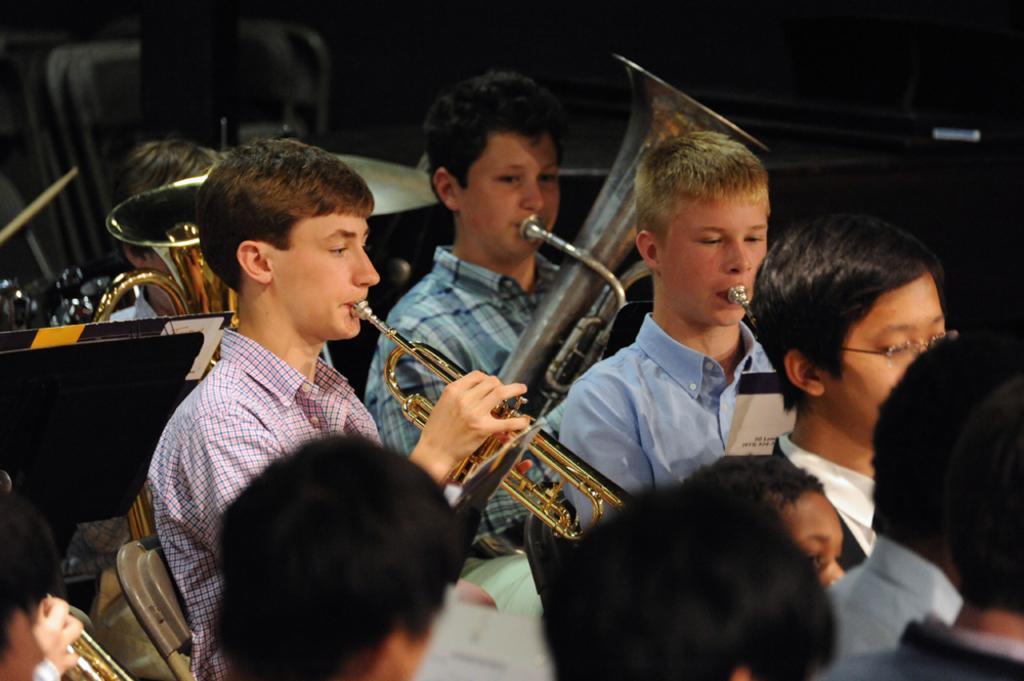Can you describe this image briefly? In this picture there are group of people playing musical instrument and there are books on the stand. 